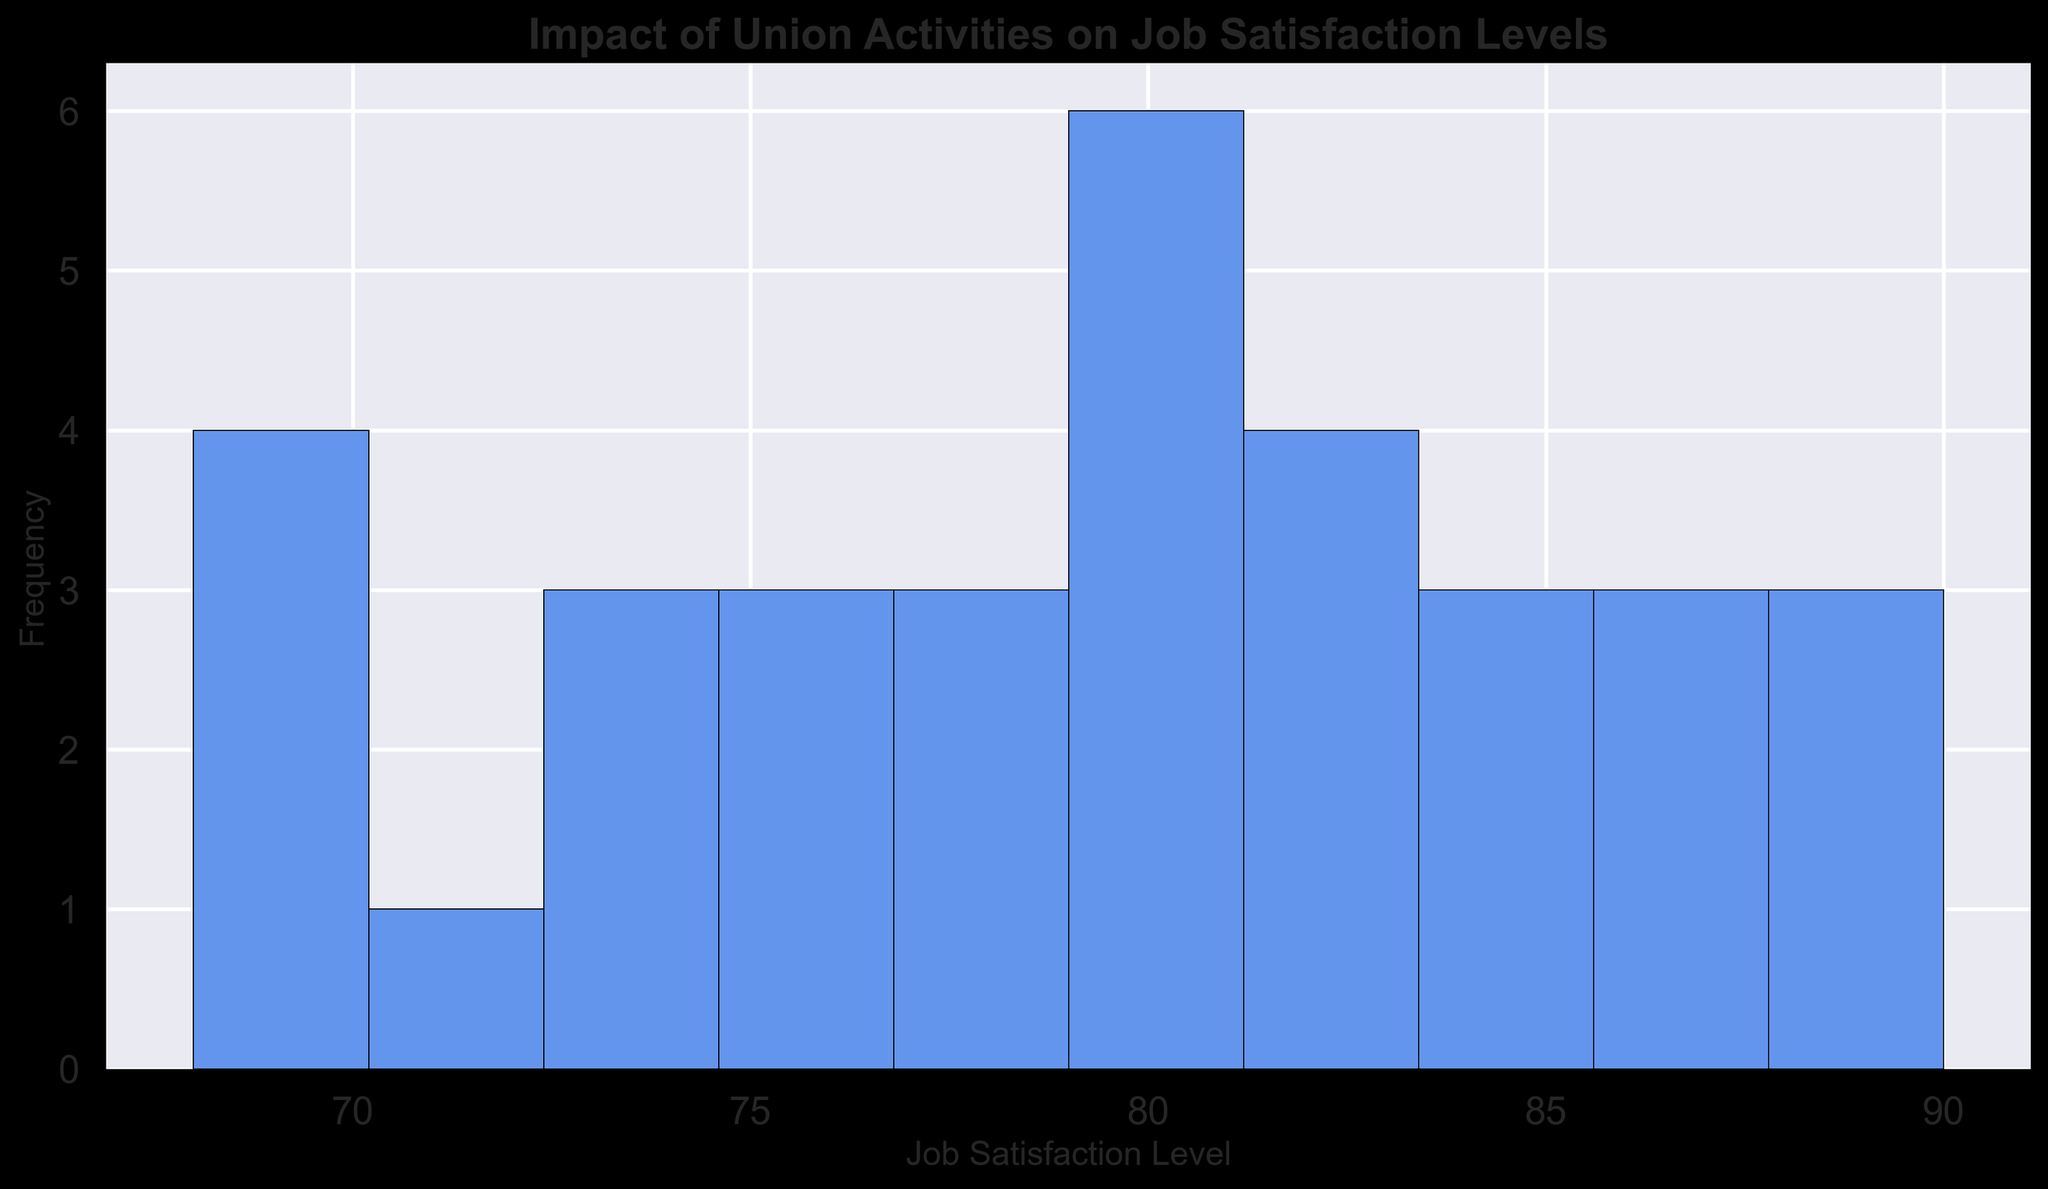How many different job satisfaction levels were recorded in the histogram? To answer this, we need to count the number of unique job satisfaction levels present in the histogram. These levels are represented by the bins in the histogram.
Answer: 10 What is the most frequent job satisfaction level in the histogram? Look at the tallest bar in the histogram; this bar represents the job satisfaction level with the highest frequency.
Answer: 85 What's the range of job satisfaction levels displayed in the histogram? Identify the lowest and highest job satisfaction levels from the x-axis of the histogram and subtract the smallest value from the largest.
Answer: 69 to 90 Which year had the highest job satisfaction level, and what was it? Refer to the data and identify the highest job satisfaction level listed. Then, find the corresponding year for that level.
Answer: 2023, 90 What is the median job satisfaction level shown in the histogram? Arrange all job satisfaction levels in ascending order and choose the middle value if there is an odd number of levels, or average the two middle values if there is an even number of levels.
Answer: 81 Is there a general upward trend in job satisfaction levels over the decade? Check the progression of job satisfaction levels from 2013 to 2023. Look for a consistent increase in values across the years.
Answer: Yes, there is an upward trend How many years recorded a job satisfaction level of 81 or above? Check the individual data points for job satisfaction levels and count how many instances are 81 or higher.
Answer: 12 years Which year had the greatest number of union activities, and what was the job satisfaction level that year? Locate the year with the highest value in the Union_Activities column and then check the corresponding job satisfaction level for that year.
Answer: 2023, 90 Is there a correlation between the number of union activities and job satisfaction levels? By observing the histogram and data, look for a pattern where higher union activities correlate with higher job satisfaction levels.
Answer: Yes, there seems to be a positive correlation Did the frequency of job satisfaction levels increase or decrease over 80 in the last three years? Examine the histogram bars representing job satisfaction levels over 80 for the last three years (2021, 2022, 2023) and compare their heights.
Answer: Increased 